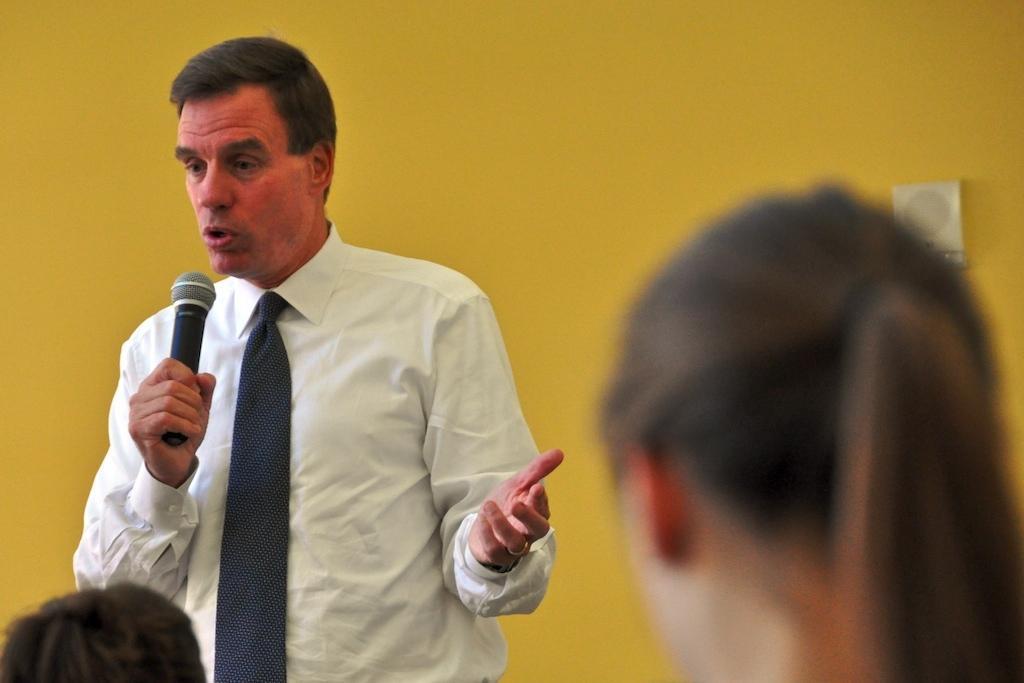Could you give a brief overview of what you see in this image? In this picture this person standing and holding microphone. Two persons are there. On the background we can see wall. 